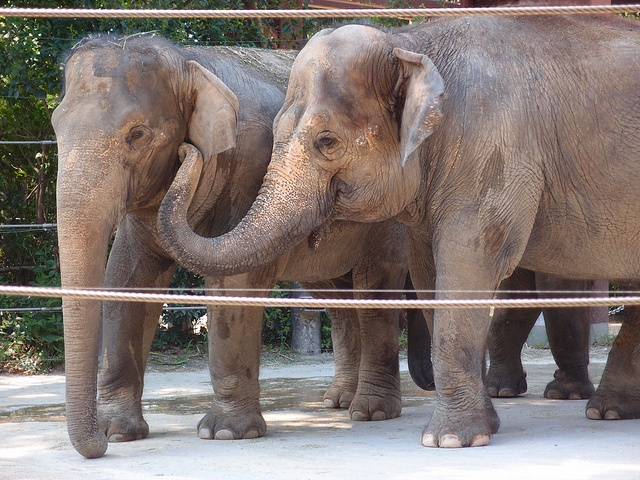Describe the objects in this image and their specific colors. I can see elephant in black, gray, and darkgray tones, elephant in black, gray, and darkgray tones, and elephant in black, gray, and darkgray tones in this image. 